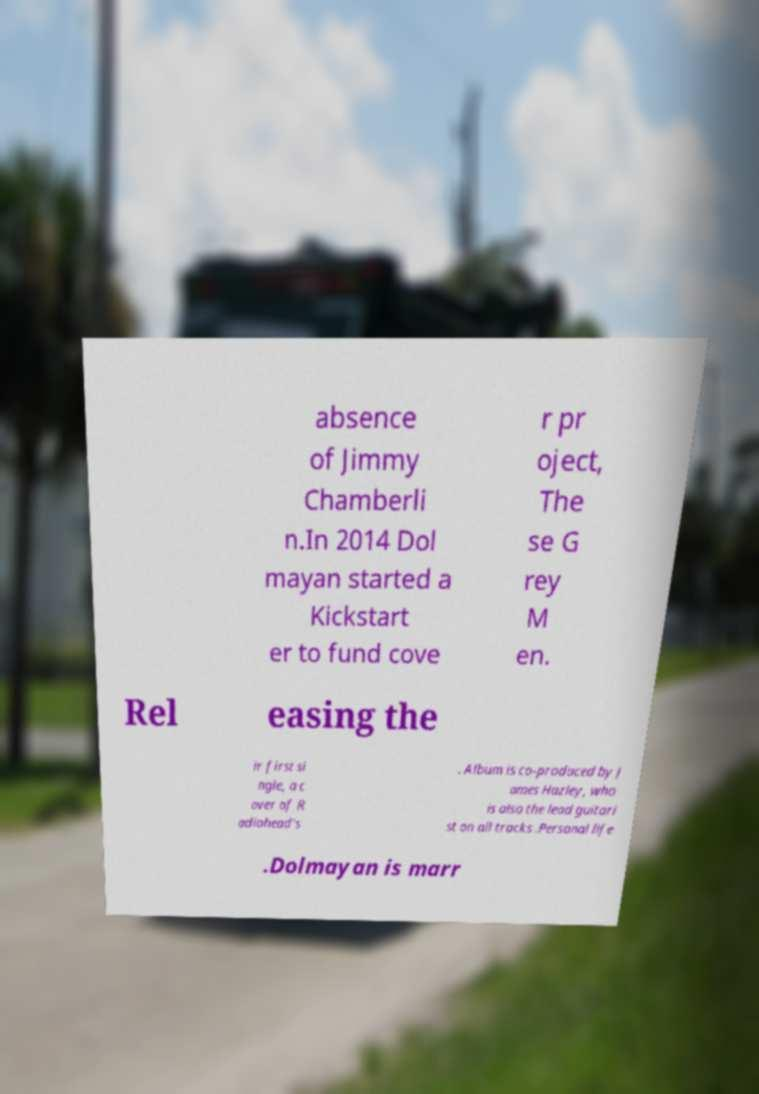Please identify and transcribe the text found in this image. absence of Jimmy Chamberli n.In 2014 Dol mayan started a Kickstart er to fund cove r pr oject, The se G rey M en. Rel easing the ir first si ngle, a c over of R adiohead's . Album is co-produced by J ames Hazley, who is also the lead guitari st on all tracks .Personal life .Dolmayan is marr 